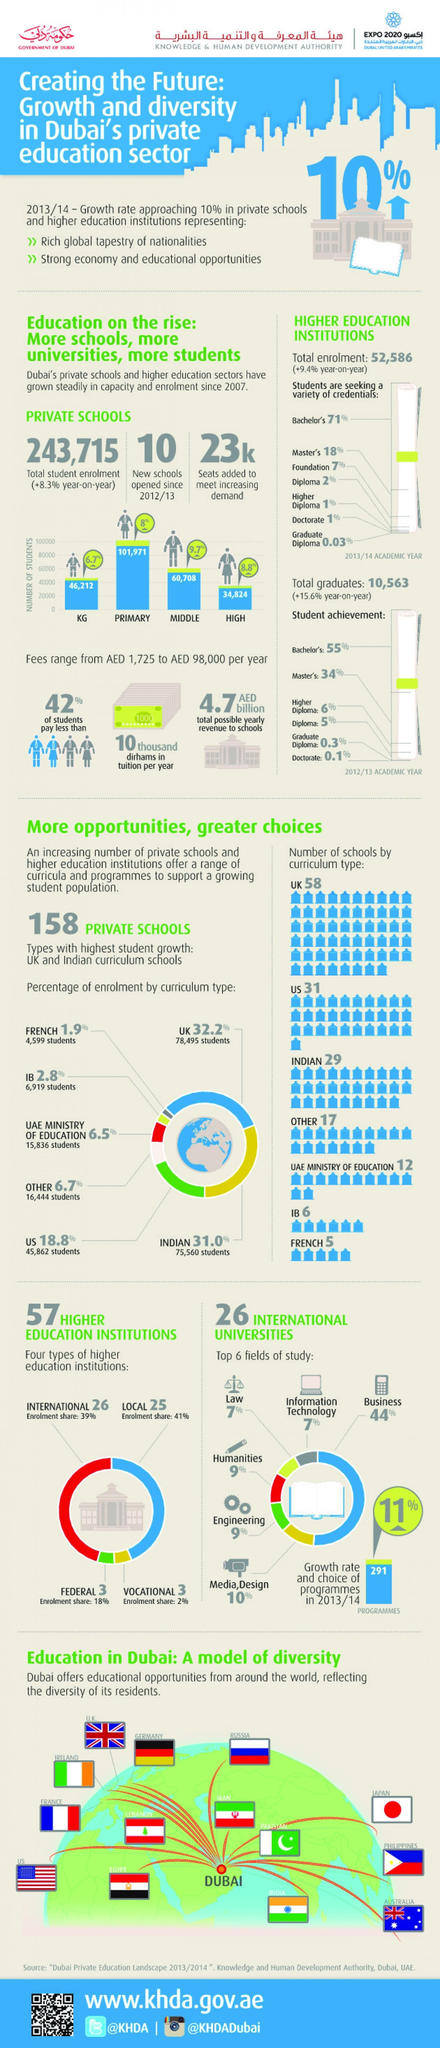What has been the yearly increase in enrolment rate in private schools
Answer the question with a short phrase. +8.3% what is the total count of schools that follow UK or Indian curriculum 87 what is the count of federal and vocational institutions 6 how many seats have been added in private schools to meet increasing demands 23K What is the total number of students in KG and high schools 81036 What has been the yearly increase in enrolment rate in higher education institutions +9.4% How many students have been enrolled in IB and French curriculum schools together 11518 